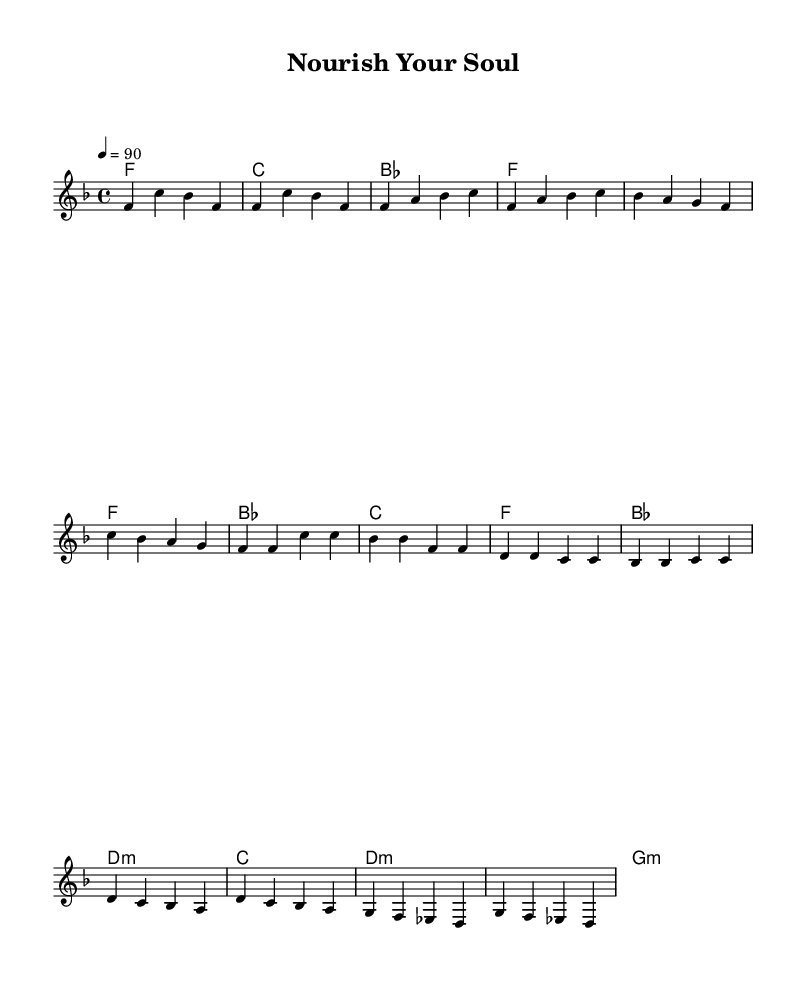What is the key signature of this music? The key signature is F major, which has one flat (B flat). This can be determined by looking at the key signature at the beginning of the staff, which indicates the specific pitches that are altered.
Answer: F major What is the time signature? The time signature is 4/4, which indicates that there are four beats in each measure (bar) and that the quarter note gets one beat. This information is found at the beginning of the piece, right after the key signature.
Answer: 4/4 What is the tempo marking? The tempo marking is 90 beats per minute, indicated by the notation "4 = 90" at the beginning of the music. This refers to a quarter note equaling 90 beats.
Answer: 90 How many measures are in the chorus section? The chorus section contains four measures. This can be counted by examining the music notation under the "Chorus" labeled section, where there are four distinct measure groups.
Answer: 4 What type of chords are used in the chorus section? The chorus section features a combination of major and minor chords, including B flat major, D minor, and C major. By analyzing the chord names written above the staff during the chorus, we can determine the types of chords used.
Answer: Major and minor What is the first note of the melody? The first note of the melody is F. By looking at the very first note of the melody section, we can see that it is notated as an F note.
Answer: F What is the interval between the first two notes of the verse? The interval between the first two notes (F and A) is a major third. By identifying the notes and comparing their positions on the staff, we can confirm the distance between the notes, which constitutes a major third.
Answer: Major third 